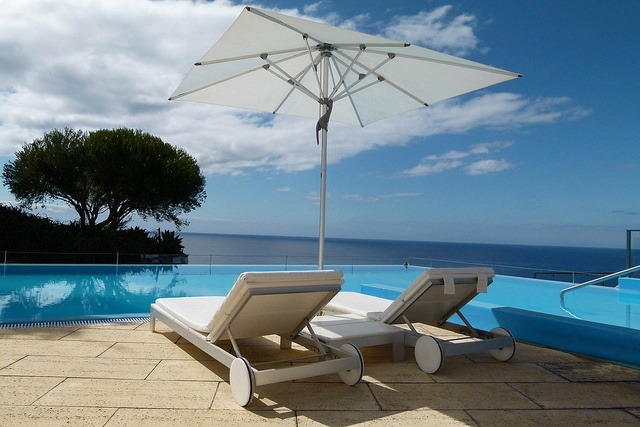Describe the objects in this image and their specific colors. I can see umbrella in white, darkgray, and lightgray tones, chair in white, gray, and lightgray tones, and chair in white, gray, black, and lightgray tones in this image. 